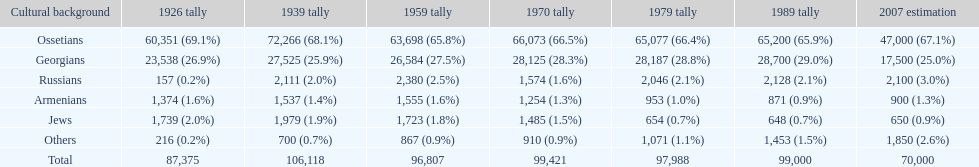In 1926, which population had the highest number of individuals? Ossetians. 